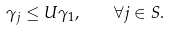<formula> <loc_0><loc_0><loc_500><loc_500>\gamma _ { j } \leq U \gamma _ { 1 } , \quad \forall j \in S .</formula> 